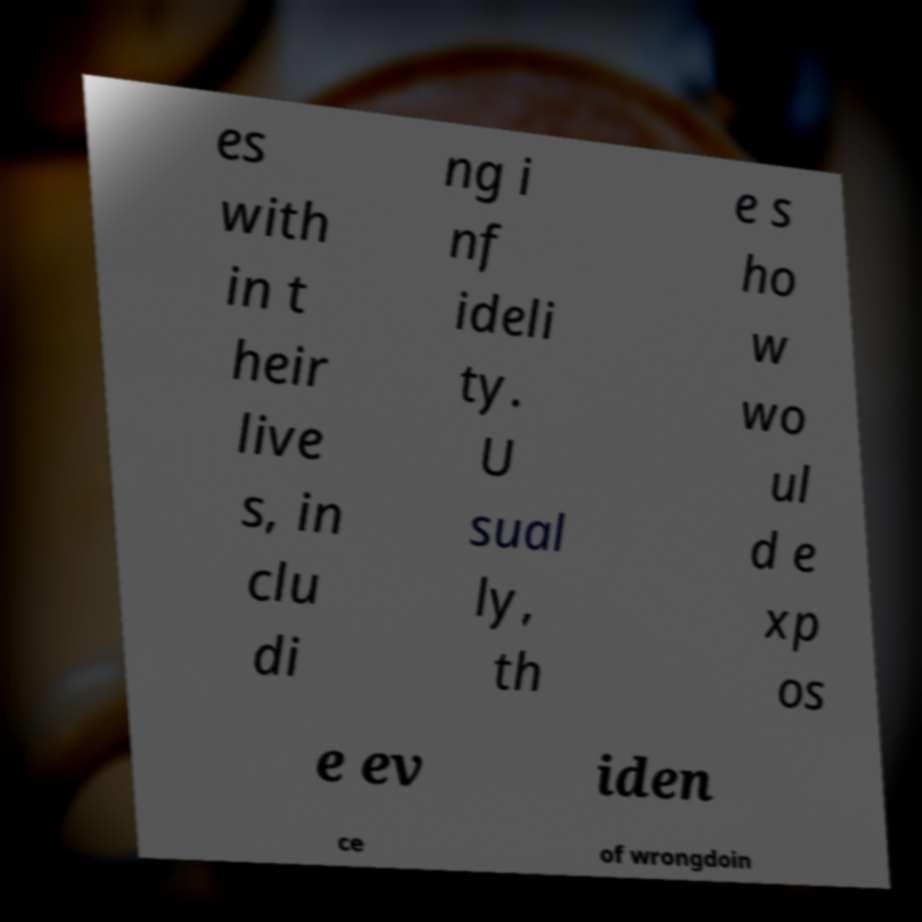Please read and relay the text visible in this image. What does it say? es with in t heir live s, in clu di ng i nf ideli ty. U sual ly, th e s ho w wo ul d e xp os e ev iden ce of wrongdoin 